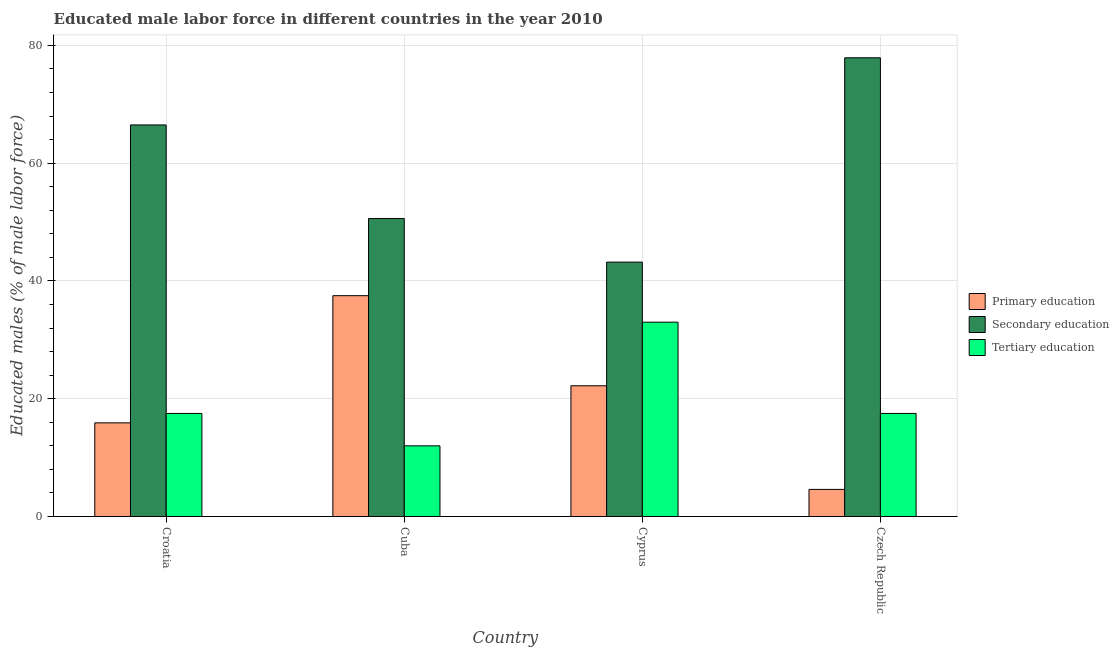How many groups of bars are there?
Your answer should be compact. 4. Are the number of bars per tick equal to the number of legend labels?
Your response must be concise. Yes. What is the label of the 4th group of bars from the left?
Keep it short and to the point. Czech Republic. In how many cases, is the number of bars for a given country not equal to the number of legend labels?
Provide a short and direct response. 0. What is the percentage of male labor force who received secondary education in Cuba?
Your answer should be compact. 50.6. Across all countries, what is the minimum percentage of male labor force who received primary education?
Provide a succinct answer. 4.6. In which country was the percentage of male labor force who received tertiary education maximum?
Provide a short and direct response. Cyprus. In which country was the percentage of male labor force who received primary education minimum?
Give a very brief answer. Czech Republic. What is the total percentage of male labor force who received secondary education in the graph?
Give a very brief answer. 238.2. What is the difference between the percentage of male labor force who received primary education in Cyprus and that in Czech Republic?
Your answer should be very brief. 17.6. What is the difference between the percentage of male labor force who received primary education in Croatia and the percentage of male labor force who received secondary education in Cuba?
Provide a short and direct response. -34.7. What is the average percentage of male labor force who received primary education per country?
Give a very brief answer. 20.05. What is the difference between the percentage of male labor force who received tertiary education and percentage of male labor force who received secondary education in Czech Republic?
Keep it short and to the point. -60.4. What is the ratio of the percentage of male labor force who received tertiary education in Cuba to that in Cyprus?
Provide a succinct answer. 0.36. What is the difference between the highest and the second highest percentage of male labor force who received primary education?
Make the answer very short. 15.3. What is the difference between the highest and the lowest percentage of male labor force who received secondary education?
Provide a succinct answer. 34.7. In how many countries, is the percentage of male labor force who received tertiary education greater than the average percentage of male labor force who received tertiary education taken over all countries?
Provide a succinct answer. 1. Is the sum of the percentage of male labor force who received primary education in Croatia and Czech Republic greater than the maximum percentage of male labor force who received secondary education across all countries?
Offer a terse response. No. What does the 1st bar from the left in Croatia represents?
Your response must be concise. Primary education. What does the 1st bar from the right in Czech Republic represents?
Offer a very short reply. Tertiary education. Is it the case that in every country, the sum of the percentage of male labor force who received primary education and percentage of male labor force who received secondary education is greater than the percentage of male labor force who received tertiary education?
Make the answer very short. Yes. Are the values on the major ticks of Y-axis written in scientific E-notation?
Ensure brevity in your answer.  No. Does the graph contain grids?
Your response must be concise. Yes. Where does the legend appear in the graph?
Offer a very short reply. Center right. How many legend labels are there?
Keep it short and to the point. 3. What is the title of the graph?
Offer a very short reply. Educated male labor force in different countries in the year 2010. What is the label or title of the Y-axis?
Provide a succinct answer. Educated males (% of male labor force). What is the Educated males (% of male labor force) in Primary education in Croatia?
Keep it short and to the point. 15.9. What is the Educated males (% of male labor force) in Secondary education in Croatia?
Make the answer very short. 66.5. What is the Educated males (% of male labor force) of Tertiary education in Croatia?
Give a very brief answer. 17.5. What is the Educated males (% of male labor force) in Primary education in Cuba?
Your answer should be compact. 37.5. What is the Educated males (% of male labor force) in Secondary education in Cuba?
Keep it short and to the point. 50.6. What is the Educated males (% of male labor force) of Tertiary education in Cuba?
Give a very brief answer. 12. What is the Educated males (% of male labor force) of Primary education in Cyprus?
Make the answer very short. 22.2. What is the Educated males (% of male labor force) in Secondary education in Cyprus?
Offer a terse response. 43.2. What is the Educated males (% of male labor force) of Tertiary education in Cyprus?
Make the answer very short. 33. What is the Educated males (% of male labor force) in Primary education in Czech Republic?
Keep it short and to the point. 4.6. What is the Educated males (% of male labor force) of Secondary education in Czech Republic?
Your answer should be compact. 77.9. Across all countries, what is the maximum Educated males (% of male labor force) in Primary education?
Provide a succinct answer. 37.5. Across all countries, what is the maximum Educated males (% of male labor force) of Secondary education?
Offer a terse response. 77.9. Across all countries, what is the minimum Educated males (% of male labor force) in Primary education?
Ensure brevity in your answer.  4.6. Across all countries, what is the minimum Educated males (% of male labor force) in Secondary education?
Keep it short and to the point. 43.2. What is the total Educated males (% of male labor force) of Primary education in the graph?
Provide a short and direct response. 80.2. What is the total Educated males (% of male labor force) in Secondary education in the graph?
Keep it short and to the point. 238.2. What is the total Educated males (% of male labor force) of Tertiary education in the graph?
Your response must be concise. 80. What is the difference between the Educated males (% of male labor force) in Primary education in Croatia and that in Cuba?
Provide a succinct answer. -21.6. What is the difference between the Educated males (% of male labor force) in Secondary education in Croatia and that in Cuba?
Keep it short and to the point. 15.9. What is the difference between the Educated males (% of male labor force) of Secondary education in Croatia and that in Cyprus?
Ensure brevity in your answer.  23.3. What is the difference between the Educated males (% of male labor force) in Tertiary education in Croatia and that in Cyprus?
Offer a terse response. -15.5. What is the difference between the Educated males (% of male labor force) of Primary education in Croatia and that in Czech Republic?
Keep it short and to the point. 11.3. What is the difference between the Educated males (% of male labor force) of Secondary education in Croatia and that in Czech Republic?
Offer a very short reply. -11.4. What is the difference between the Educated males (% of male labor force) in Tertiary education in Cuba and that in Cyprus?
Give a very brief answer. -21. What is the difference between the Educated males (% of male labor force) of Primary education in Cuba and that in Czech Republic?
Ensure brevity in your answer.  32.9. What is the difference between the Educated males (% of male labor force) in Secondary education in Cuba and that in Czech Republic?
Ensure brevity in your answer.  -27.3. What is the difference between the Educated males (% of male labor force) of Tertiary education in Cuba and that in Czech Republic?
Give a very brief answer. -5.5. What is the difference between the Educated males (% of male labor force) of Secondary education in Cyprus and that in Czech Republic?
Provide a short and direct response. -34.7. What is the difference between the Educated males (% of male labor force) of Tertiary education in Cyprus and that in Czech Republic?
Make the answer very short. 15.5. What is the difference between the Educated males (% of male labor force) in Primary education in Croatia and the Educated males (% of male labor force) in Secondary education in Cuba?
Your answer should be very brief. -34.7. What is the difference between the Educated males (% of male labor force) in Primary education in Croatia and the Educated males (% of male labor force) in Tertiary education in Cuba?
Keep it short and to the point. 3.9. What is the difference between the Educated males (% of male labor force) in Secondary education in Croatia and the Educated males (% of male labor force) in Tertiary education in Cuba?
Ensure brevity in your answer.  54.5. What is the difference between the Educated males (% of male labor force) of Primary education in Croatia and the Educated males (% of male labor force) of Secondary education in Cyprus?
Your response must be concise. -27.3. What is the difference between the Educated males (% of male labor force) of Primary education in Croatia and the Educated males (% of male labor force) of Tertiary education in Cyprus?
Offer a terse response. -17.1. What is the difference between the Educated males (% of male labor force) of Secondary education in Croatia and the Educated males (% of male labor force) of Tertiary education in Cyprus?
Provide a succinct answer. 33.5. What is the difference between the Educated males (% of male labor force) in Primary education in Croatia and the Educated males (% of male labor force) in Secondary education in Czech Republic?
Provide a short and direct response. -62. What is the difference between the Educated males (% of male labor force) in Secondary education in Croatia and the Educated males (% of male labor force) in Tertiary education in Czech Republic?
Provide a succinct answer. 49. What is the difference between the Educated males (% of male labor force) of Primary education in Cuba and the Educated males (% of male labor force) of Secondary education in Cyprus?
Offer a very short reply. -5.7. What is the difference between the Educated males (% of male labor force) in Primary education in Cuba and the Educated males (% of male labor force) in Tertiary education in Cyprus?
Your answer should be very brief. 4.5. What is the difference between the Educated males (% of male labor force) of Secondary education in Cuba and the Educated males (% of male labor force) of Tertiary education in Cyprus?
Provide a succinct answer. 17.6. What is the difference between the Educated males (% of male labor force) of Primary education in Cuba and the Educated males (% of male labor force) of Secondary education in Czech Republic?
Make the answer very short. -40.4. What is the difference between the Educated males (% of male labor force) in Primary education in Cuba and the Educated males (% of male labor force) in Tertiary education in Czech Republic?
Provide a short and direct response. 20. What is the difference between the Educated males (% of male labor force) in Secondary education in Cuba and the Educated males (% of male labor force) in Tertiary education in Czech Republic?
Offer a terse response. 33.1. What is the difference between the Educated males (% of male labor force) of Primary education in Cyprus and the Educated males (% of male labor force) of Secondary education in Czech Republic?
Give a very brief answer. -55.7. What is the difference between the Educated males (% of male labor force) in Primary education in Cyprus and the Educated males (% of male labor force) in Tertiary education in Czech Republic?
Your answer should be compact. 4.7. What is the difference between the Educated males (% of male labor force) of Secondary education in Cyprus and the Educated males (% of male labor force) of Tertiary education in Czech Republic?
Give a very brief answer. 25.7. What is the average Educated males (% of male labor force) in Primary education per country?
Offer a very short reply. 20.05. What is the average Educated males (% of male labor force) of Secondary education per country?
Offer a very short reply. 59.55. What is the difference between the Educated males (% of male labor force) in Primary education and Educated males (% of male labor force) in Secondary education in Croatia?
Ensure brevity in your answer.  -50.6. What is the difference between the Educated males (% of male labor force) in Primary education and Educated males (% of male labor force) in Tertiary education in Croatia?
Provide a succinct answer. -1.6. What is the difference between the Educated males (% of male labor force) of Secondary education and Educated males (% of male labor force) of Tertiary education in Croatia?
Provide a short and direct response. 49. What is the difference between the Educated males (% of male labor force) in Primary education and Educated males (% of male labor force) in Tertiary education in Cuba?
Provide a succinct answer. 25.5. What is the difference between the Educated males (% of male labor force) in Secondary education and Educated males (% of male labor force) in Tertiary education in Cuba?
Your response must be concise. 38.6. What is the difference between the Educated males (% of male labor force) of Primary education and Educated males (% of male labor force) of Secondary education in Cyprus?
Your response must be concise. -21. What is the difference between the Educated males (% of male labor force) in Primary education and Educated males (% of male labor force) in Secondary education in Czech Republic?
Offer a very short reply. -73.3. What is the difference between the Educated males (% of male labor force) of Secondary education and Educated males (% of male labor force) of Tertiary education in Czech Republic?
Offer a terse response. 60.4. What is the ratio of the Educated males (% of male labor force) in Primary education in Croatia to that in Cuba?
Provide a succinct answer. 0.42. What is the ratio of the Educated males (% of male labor force) of Secondary education in Croatia to that in Cuba?
Give a very brief answer. 1.31. What is the ratio of the Educated males (% of male labor force) in Tertiary education in Croatia to that in Cuba?
Provide a succinct answer. 1.46. What is the ratio of the Educated males (% of male labor force) in Primary education in Croatia to that in Cyprus?
Make the answer very short. 0.72. What is the ratio of the Educated males (% of male labor force) of Secondary education in Croatia to that in Cyprus?
Your answer should be compact. 1.54. What is the ratio of the Educated males (% of male labor force) in Tertiary education in Croatia to that in Cyprus?
Your response must be concise. 0.53. What is the ratio of the Educated males (% of male labor force) of Primary education in Croatia to that in Czech Republic?
Offer a very short reply. 3.46. What is the ratio of the Educated males (% of male labor force) of Secondary education in Croatia to that in Czech Republic?
Provide a succinct answer. 0.85. What is the ratio of the Educated males (% of male labor force) of Primary education in Cuba to that in Cyprus?
Make the answer very short. 1.69. What is the ratio of the Educated males (% of male labor force) in Secondary education in Cuba to that in Cyprus?
Your answer should be very brief. 1.17. What is the ratio of the Educated males (% of male labor force) in Tertiary education in Cuba to that in Cyprus?
Keep it short and to the point. 0.36. What is the ratio of the Educated males (% of male labor force) of Primary education in Cuba to that in Czech Republic?
Ensure brevity in your answer.  8.15. What is the ratio of the Educated males (% of male labor force) of Secondary education in Cuba to that in Czech Republic?
Provide a succinct answer. 0.65. What is the ratio of the Educated males (% of male labor force) of Tertiary education in Cuba to that in Czech Republic?
Provide a succinct answer. 0.69. What is the ratio of the Educated males (% of male labor force) of Primary education in Cyprus to that in Czech Republic?
Your answer should be very brief. 4.83. What is the ratio of the Educated males (% of male labor force) in Secondary education in Cyprus to that in Czech Republic?
Make the answer very short. 0.55. What is the ratio of the Educated males (% of male labor force) of Tertiary education in Cyprus to that in Czech Republic?
Offer a terse response. 1.89. What is the difference between the highest and the second highest Educated males (% of male labor force) in Primary education?
Provide a short and direct response. 15.3. What is the difference between the highest and the second highest Educated males (% of male labor force) in Secondary education?
Your response must be concise. 11.4. What is the difference between the highest and the lowest Educated males (% of male labor force) of Primary education?
Ensure brevity in your answer.  32.9. What is the difference between the highest and the lowest Educated males (% of male labor force) in Secondary education?
Your response must be concise. 34.7. What is the difference between the highest and the lowest Educated males (% of male labor force) in Tertiary education?
Ensure brevity in your answer.  21. 